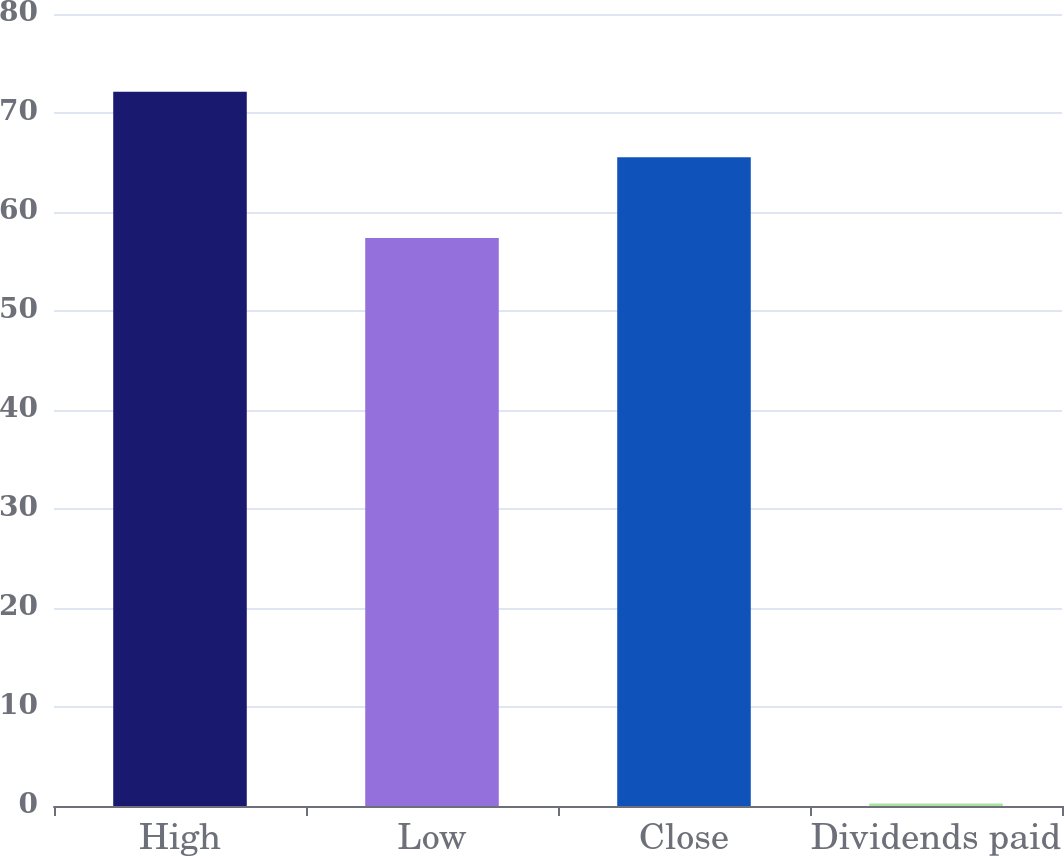Convert chart to OTSL. <chart><loc_0><loc_0><loc_500><loc_500><bar_chart><fcel>High<fcel>Low<fcel>Close<fcel>Dividends paid<nl><fcel>72.14<fcel>57.38<fcel>65.52<fcel>0.25<nl></chart> 